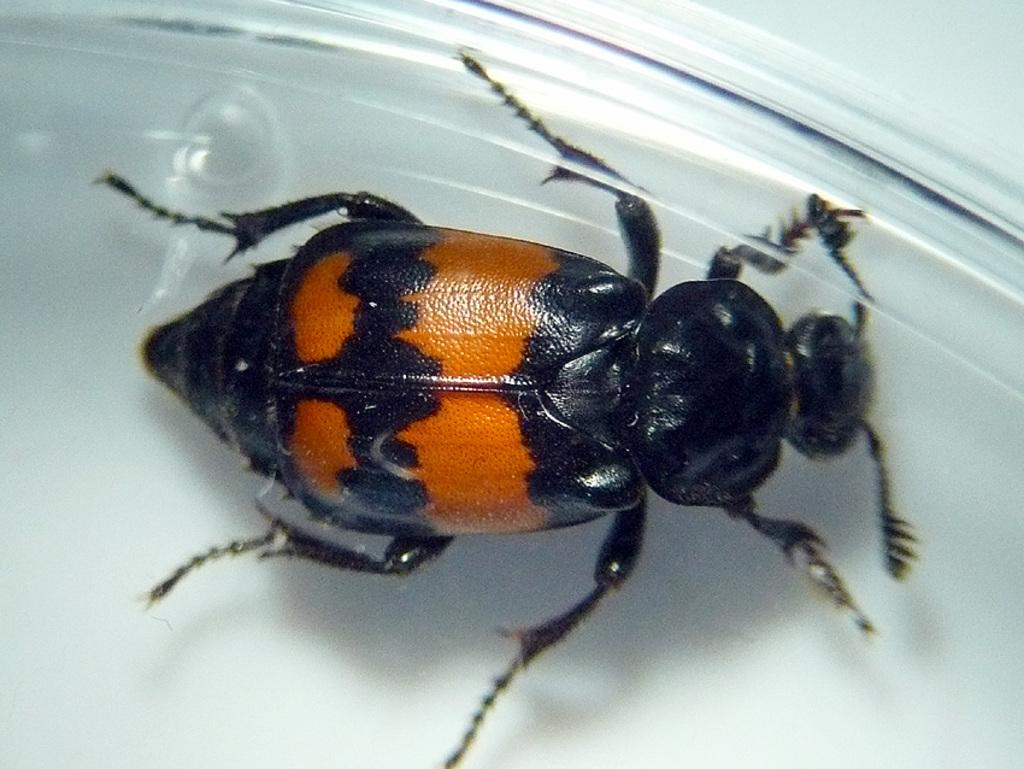What type of creature can be seen in the image? There is an insect in the image. What is the color of the surface in the background of the image? The surface in the background of the image is white. Where is the scarecrow located in the image? There is no scarecrow present in the image. What type of berry can be seen growing on the insect in the image? There are no berries present in the image, and the insect is not a plant that could grow berries. 